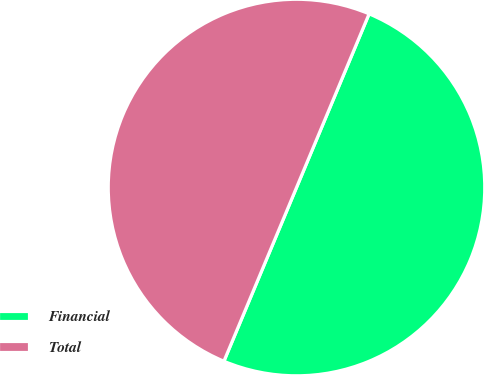Convert chart. <chart><loc_0><loc_0><loc_500><loc_500><pie_chart><fcel>Financial<fcel>Total<nl><fcel>50.0%<fcel>50.0%<nl></chart> 